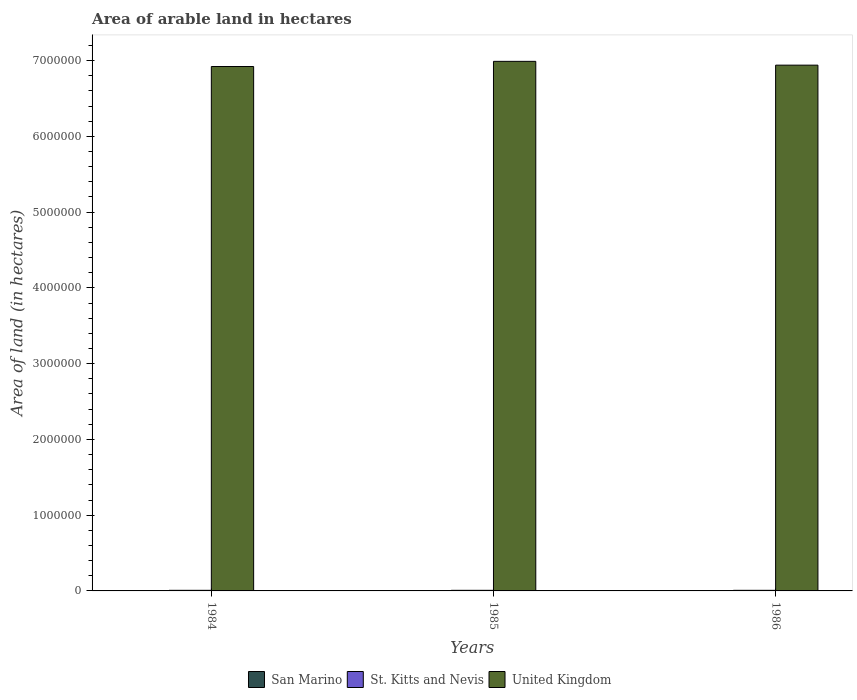How many different coloured bars are there?
Give a very brief answer. 3. How many groups of bars are there?
Your answer should be compact. 3. What is the label of the 1st group of bars from the left?
Give a very brief answer. 1984. What is the total arable land in San Marino in 1986?
Your response must be concise. 1000. Across all years, what is the maximum total arable land in United Kingdom?
Your answer should be very brief. 6.99e+06. Across all years, what is the minimum total arable land in San Marino?
Keep it short and to the point. 1000. In which year was the total arable land in San Marino maximum?
Keep it short and to the point. 1984. What is the total total arable land in San Marino in the graph?
Offer a very short reply. 3000. What is the difference between the total arable land in St. Kitts and Nevis in 1986 and the total arable land in San Marino in 1985?
Offer a very short reply. 7000. What is the average total arable land in San Marino per year?
Your answer should be compact. 1000. In the year 1984, what is the difference between the total arable land in St. Kitts and Nevis and total arable land in San Marino?
Offer a terse response. 7000. What is the ratio of the total arable land in St. Kitts and Nevis in 1984 to that in 1985?
Your answer should be compact. 1. Is the total arable land in United Kingdom in 1984 less than that in 1986?
Your answer should be very brief. Yes. What is the difference between the highest and the lowest total arable land in United Kingdom?
Your response must be concise. 6.80e+04. What does the 1st bar from the left in 1986 represents?
Keep it short and to the point. San Marino. What does the 2nd bar from the right in 1985 represents?
Offer a terse response. St. Kitts and Nevis. How many bars are there?
Your answer should be very brief. 9. Are all the bars in the graph horizontal?
Your response must be concise. No. What is the difference between two consecutive major ticks on the Y-axis?
Provide a succinct answer. 1.00e+06. Does the graph contain any zero values?
Ensure brevity in your answer.  No. Does the graph contain grids?
Your response must be concise. No. How are the legend labels stacked?
Offer a terse response. Horizontal. What is the title of the graph?
Provide a short and direct response. Area of arable land in hectares. What is the label or title of the Y-axis?
Provide a short and direct response. Area of land (in hectares). What is the Area of land (in hectares) of San Marino in 1984?
Make the answer very short. 1000. What is the Area of land (in hectares) of St. Kitts and Nevis in 1984?
Provide a short and direct response. 8000. What is the Area of land (in hectares) of United Kingdom in 1984?
Your answer should be compact. 6.92e+06. What is the Area of land (in hectares) of St. Kitts and Nevis in 1985?
Offer a terse response. 8000. What is the Area of land (in hectares) of United Kingdom in 1985?
Your answer should be very brief. 6.99e+06. What is the Area of land (in hectares) of San Marino in 1986?
Offer a terse response. 1000. What is the Area of land (in hectares) of St. Kitts and Nevis in 1986?
Make the answer very short. 8000. What is the Area of land (in hectares) in United Kingdom in 1986?
Your response must be concise. 6.94e+06. Across all years, what is the maximum Area of land (in hectares) in San Marino?
Provide a short and direct response. 1000. Across all years, what is the maximum Area of land (in hectares) in St. Kitts and Nevis?
Your response must be concise. 8000. Across all years, what is the maximum Area of land (in hectares) of United Kingdom?
Your answer should be compact. 6.99e+06. Across all years, what is the minimum Area of land (in hectares) in San Marino?
Your answer should be very brief. 1000. Across all years, what is the minimum Area of land (in hectares) in St. Kitts and Nevis?
Provide a short and direct response. 8000. Across all years, what is the minimum Area of land (in hectares) of United Kingdom?
Keep it short and to the point. 6.92e+06. What is the total Area of land (in hectares) in San Marino in the graph?
Provide a succinct answer. 3000. What is the total Area of land (in hectares) of St. Kitts and Nevis in the graph?
Your answer should be very brief. 2.40e+04. What is the total Area of land (in hectares) of United Kingdom in the graph?
Keep it short and to the point. 2.09e+07. What is the difference between the Area of land (in hectares) of St. Kitts and Nevis in 1984 and that in 1985?
Offer a very short reply. 0. What is the difference between the Area of land (in hectares) of United Kingdom in 1984 and that in 1985?
Your answer should be very brief. -6.80e+04. What is the difference between the Area of land (in hectares) in United Kingdom in 1984 and that in 1986?
Give a very brief answer. -1.80e+04. What is the difference between the Area of land (in hectares) of San Marino in 1985 and that in 1986?
Make the answer very short. 0. What is the difference between the Area of land (in hectares) in St. Kitts and Nevis in 1985 and that in 1986?
Provide a short and direct response. 0. What is the difference between the Area of land (in hectares) in San Marino in 1984 and the Area of land (in hectares) in St. Kitts and Nevis in 1985?
Ensure brevity in your answer.  -7000. What is the difference between the Area of land (in hectares) in San Marino in 1984 and the Area of land (in hectares) in United Kingdom in 1985?
Provide a succinct answer. -6.99e+06. What is the difference between the Area of land (in hectares) of St. Kitts and Nevis in 1984 and the Area of land (in hectares) of United Kingdom in 1985?
Provide a short and direct response. -6.98e+06. What is the difference between the Area of land (in hectares) in San Marino in 1984 and the Area of land (in hectares) in St. Kitts and Nevis in 1986?
Keep it short and to the point. -7000. What is the difference between the Area of land (in hectares) in San Marino in 1984 and the Area of land (in hectares) in United Kingdom in 1986?
Your response must be concise. -6.94e+06. What is the difference between the Area of land (in hectares) in St. Kitts and Nevis in 1984 and the Area of land (in hectares) in United Kingdom in 1986?
Your response must be concise. -6.93e+06. What is the difference between the Area of land (in hectares) in San Marino in 1985 and the Area of land (in hectares) in St. Kitts and Nevis in 1986?
Ensure brevity in your answer.  -7000. What is the difference between the Area of land (in hectares) of San Marino in 1985 and the Area of land (in hectares) of United Kingdom in 1986?
Your answer should be very brief. -6.94e+06. What is the difference between the Area of land (in hectares) in St. Kitts and Nevis in 1985 and the Area of land (in hectares) in United Kingdom in 1986?
Offer a terse response. -6.93e+06. What is the average Area of land (in hectares) in St. Kitts and Nevis per year?
Your response must be concise. 8000. What is the average Area of land (in hectares) in United Kingdom per year?
Your answer should be compact. 6.95e+06. In the year 1984, what is the difference between the Area of land (in hectares) of San Marino and Area of land (in hectares) of St. Kitts and Nevis?
Your response must be concise. -7000. In the year 1984, what is the difference between the Area of land (in hectares) of San Marino and Area of land (in hectares) of United Kingdom?
Give a very brief answer. -6.92e+06. In the year 1984, what is the difference between the Area of land (in hectares) of St. Kitts and Nevis and Area of land (in hectares) of United Kingdom?
Ensure brevity in your answer.  -6.91e+06. In the year 1985, what is the difference between the Area of land (in hectares) of San Marino and Area of land (in hectares) of St. Kitts and Nevis?
Offer a terse response. -7000. In the year 1985, what is the difference between the Area of land (in hectares) in San Marino and Area of land (in hectares) in United Kingdom?
Your answer should be compact. -6.99e+06. In the year 1985, what is the difference between the Area of land (in hectares) in St. Kitts and Nevis and Area of land (in hectares) in United Kingdom?
Your response must be concise. -6.98e+06. In the year 1986, what is the difference between the Area of land (in hectares) in San Marino and Area of land (in hectares) in St. Kitts and Nevis?
Your answer should be very brief. -7000. In the year 1986, what is the difference between the Area of land (in hectares) in San Marino and Area of land (in hectares) in United Kingdom?
Keep it short and to the point. -6.94e+06. In the year 1986, what is the difference between the Area of land (in hectares) of St. Kitts and Nevis and Area of land (in hectares) of United Kingdom?
Your answer should be very brief. -6.93e+06. What is the ratio of the Area of land (in hectares) of San Marino in 1984 to that in 1985?
Ensure brevity in your answer.  1. What is the ratio of the Area of land (in hectares) in St. Kitts and Nevis in 1984 to that in 1985?
Your answer should be very brief. 1. What is the ratio of the Area of land (in hectares) of United Kingdom in 1984 to that in 1985?
Provide a succinct answer. 0.99. What is the ratio of the Area of land (in hectares) in San Marino in 1984 to that in 1986?
Provide a succinct answer. 1. What is the ratio of the Area of land (in hectares) of United Kingdom in 1984 to that in 1986?
Keep it short and to the point. 1. What is the ratio of the Area of land (in hectares) of United Kingdom in 1985 to that in 1986?
Ensure brevity in your answer.  1.01. What is the difference between the highest and the second highest Area of land (in hectares) in St. Kitts and Nevis?
Offer a terse response. 0. What is the difference between the highest and the second highest Area of land (in hectares) of United Kingdom?
Your answer should be compact. 5.00e+04. What is the difference between the highest and the lowest Area of land (in hectares) in United Kingdom?
Provide a short and direct response. 6.80e+04. 